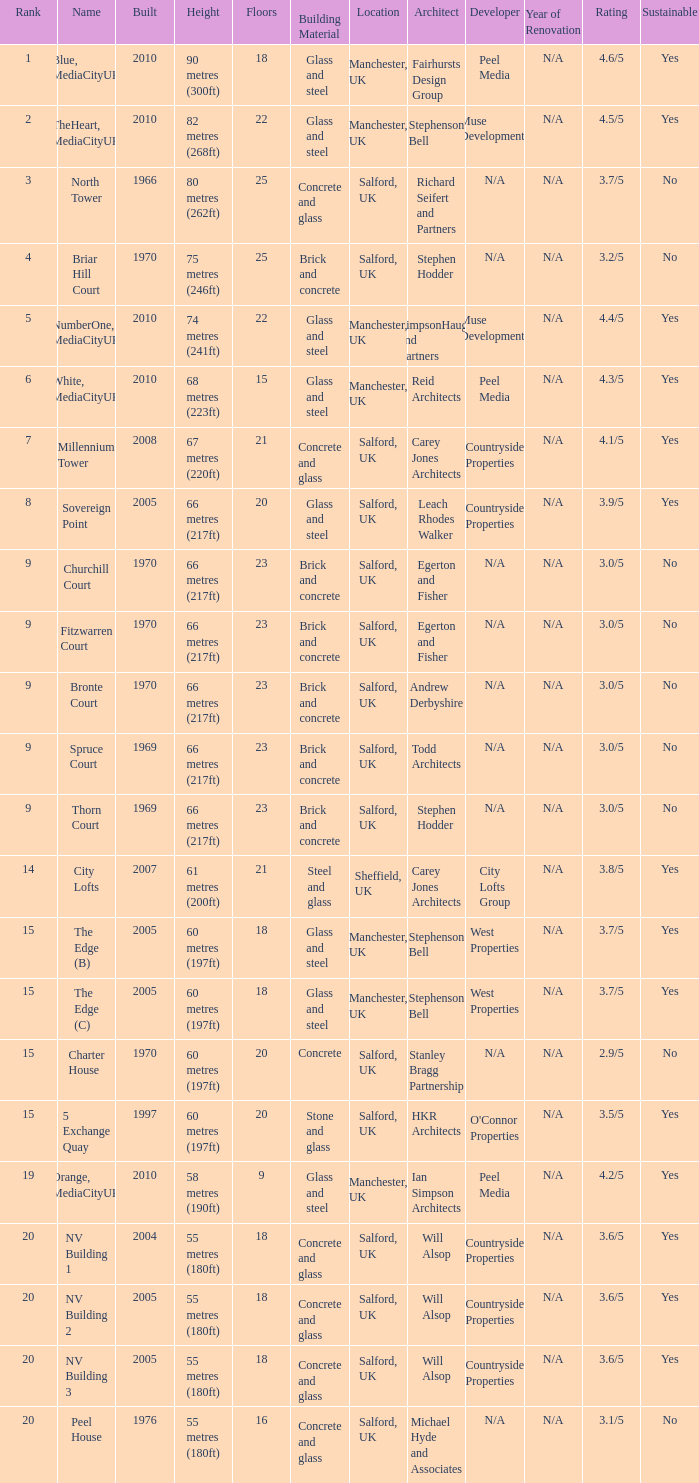What is the lowest Built, when Floors is greater than 23, and when Rank is 3? 1966.0. 